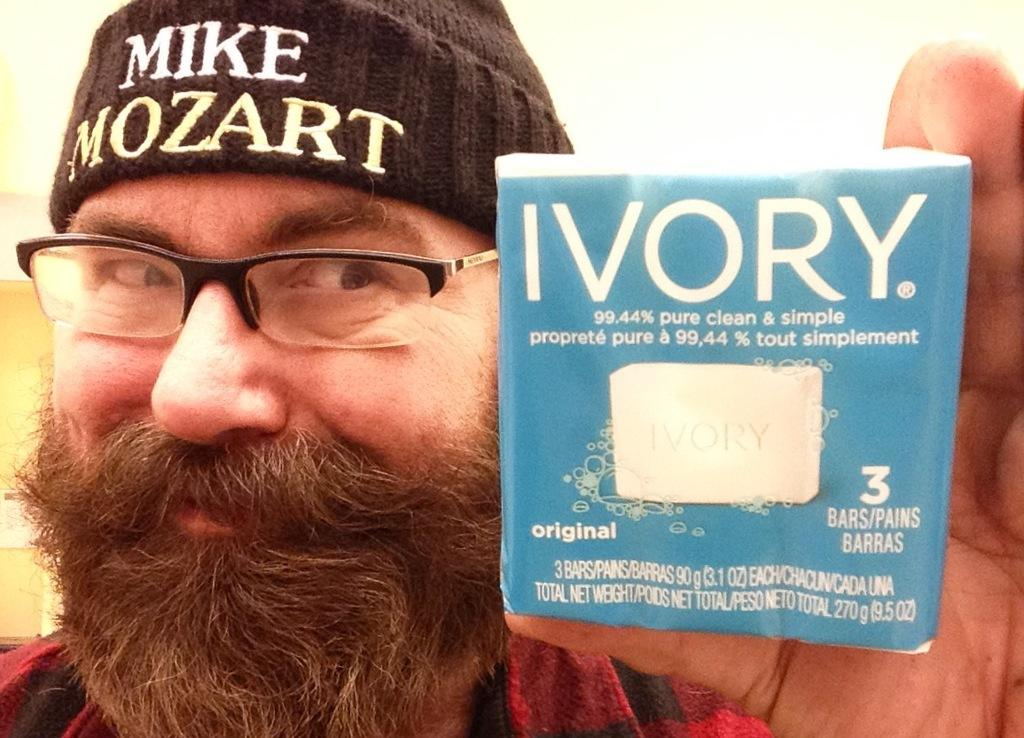Who is present in the image? There is a man in the image. What is the man holding in the image? The man is holding a blue object. What type of clothing is the man wearing on his head? The man is wearing a black cap. Reasoning: Let's think step by following the guidelines to produce the conversation. We start by identifying the main subject in the image, which is the man. Then, we expand the conversation to include other details about the man, such as the object he is holding and the cap he is wearing. Each question is designed to elicit a specific detail about the image that is known from the provided facts. Absurd Question/Answer: What type of ink is the man using to write a joke on the hose in the image? There is no ink, joke, or hose present in the image. 